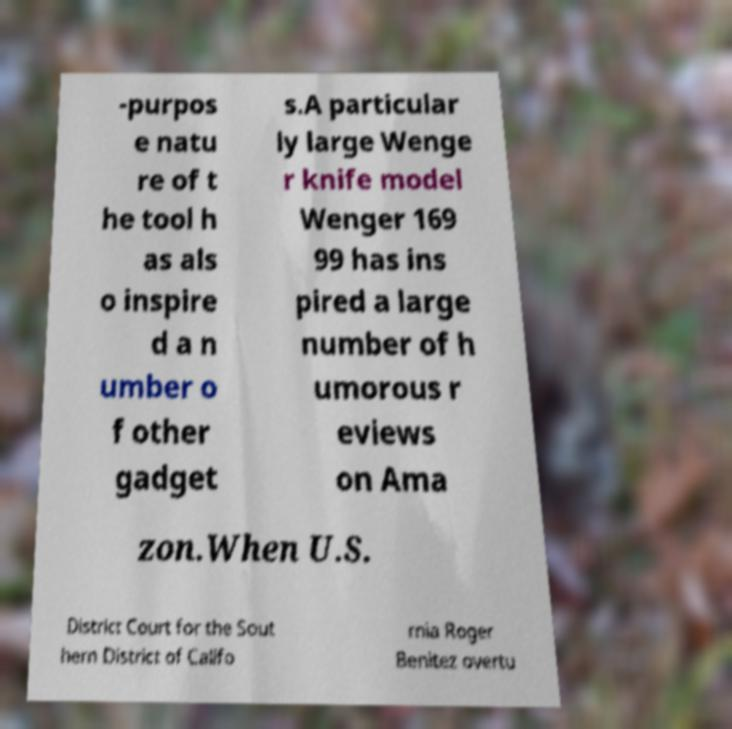Could you extract and type out the text from this image? -purpos e natu re of t he tool h as als o inspire d a n umber o f other gadget s.A particular ly large Wenge r knife model Wenger 169 99 has ins pired a large number of h umorous r eviews on Ama zon.When U.S. District Court for the Sout hern District of Califo rnia Roger Benitez overtu 